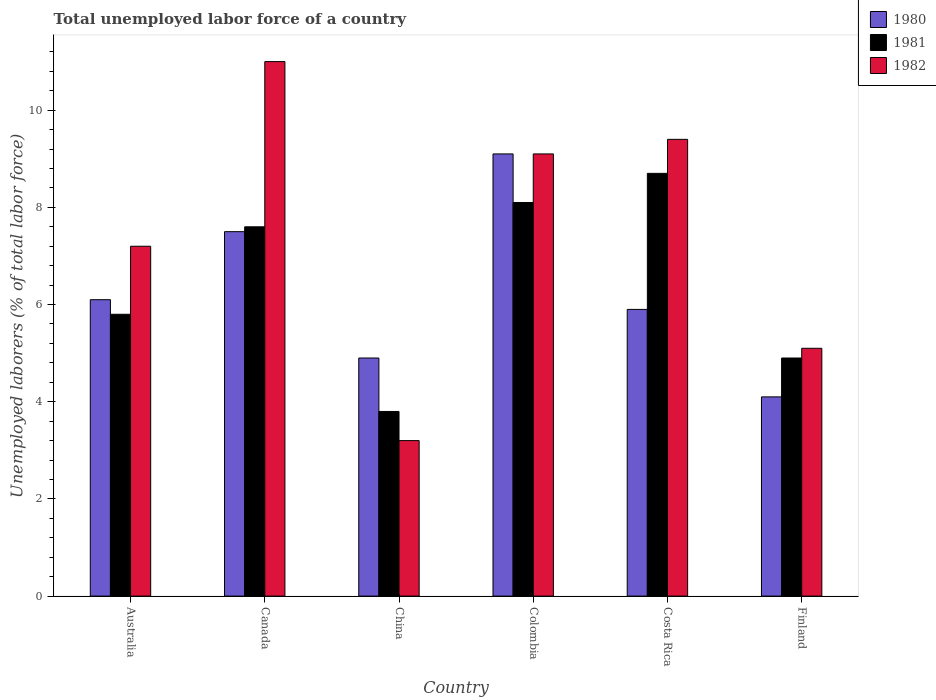How many groups of bars are there?
Your answer should be compact. 6. Are the number of bars on each tick of the X-axis equal?
Your answer should be compact. Yes. How many bars are there on the 4th tick from the right?
Keep it short and to the point. 3. What is the label of the 4th group of bars from the left?
Ensure brevity in your answer.  Colombia. In how many cases, is the number of bars for a given country not equal to the number of legend labels?
Keep it short and to the point. 0. What is the total unemployed labor force in 1982 in Finland?
Ensure brevity in your answer.  5.1. Across all countries, what is the maximum total unemployed labor force in 1980?
Offer a terse response. 9.1. Across all countries, what is the minimum total unemployed labor force in 1981?
Your response must be concise. 3.8. In which country was the total unemployed labor force in 1980 maximum?
Provide a short and direct response. Colombia. In which country was the total unemployed labor force in 1980 minimum?
Your answer should be compact. Finland. What is the total total unemployed labor force in 1981 in the graph?
Provide a short and direct response. 38.9. What is the difference between the total unemployed labor force in 1982 in Australia and that in Costa Rica?
Give a very brief answer. -2.2. What is the difference between the total unemployed labor force in 1981 in China and the total unemployed labor force in 1980 in Colombia?
Keep it short and to the point. -5.3. What is the average total unemployed labor force in 1981 per country?
Provide a succinct answer. 6.48. What is the difference between the total unemployed labor force of/in 1982 and total unemployed labor force of/in 1980 in Finland?
Keep it short and to the point. 1. What is the ratio of the total unemployed labor force in 1982 in China to that in Costa Rica?
Provide a succinct answer. 0.34. What is the difference between the highest and the second highest total unemployed labor force in 1981?
Your response must be concise. 0.6. What is the difference between the highest and the lowest total unemployed labor force in 1980?
Keep it short and to the point. 5. Is the sum of the total unemployed labor force in 1980 in Colombia and Costa Rica greater than the maximum total unemployed labor force in 1982 across all countries?
Offer a terse response. Yes. What does the 1st bar from the right in Costa Rica represents?
Your response must be concise. 1982. Is it the case that in every country, the sum of the total unemployed labor force in 1981 and total unemployed labor force in 1980 is greater than the total unemployed labor force in 1982?
Offer a terse response. Yes. How many bars are there?
Provide a short and direct response. 18. How many countries are there in the graph?
Your response must be concise. 6. Are the values on the major ticks of Y-axis written in scientific E-notation?
Provide a short and direct response. No. Does the graph contain any zero values?
Provide a short and direct response. No. How are the legend labels stacked?
Offer a very short reply. Vertical. What is the title of the graph?
Provide a short and direct response. Total unemployed labor force of a country. Does "1976" appear as one of the legend labels in the graph?
Ensure brevity in your answer.  No. What is the label or title of the X-axis?
Your answer should be compact. Country. What is the label or title of the Y-axis?
Offer a terse response. Unemployed laborers (% of total labor force). What is the Unemployed laborers (% of total labor force) in 1980 in Australia?
Your answer should be compact. 6.1. What is the Unemployed laborers (% of total labor force) in 1981 in Australia?
Your response must be concise. 5.8. What is the Unemployed laborers (% of total labor force) of 1982 in Australia?
Ensure brevity in your answer.  7.2. What is the Unemployed laborers (% of total labor force) in 1980 in Canada?
Your answer should be compact. 7.5. What is the Unemployed laborers (% of total labor force) in 1981 in Canada?
Keep it short and to the point. 7.6. What is the Unemployed laborers (% of total labor force) of 1982 in Canada?
Provide a short and direct response. 11. What is the Unemployed laborers (% of total labor force) in 1980 in China?
Give a very brief answer. 4.9. What is the Unemployed laborers (% of total labor force) of 1981 in China?
Make the answer very short. 3.8. What is the Unemployed laborers (% of total labor force) in 1982 in China?
Keep it short and to the point. 3.2. What is the Unemployed laborers (% of total labor force) of 1980 in Colombia?
Provide a succinct answer. 9.1. What is the Unemployed laborers (% of total labor force) of 1981 in Colombia?
Your answer should be compact. 8.1. What is the Unemployed laborers (% of total labor force) of 1982 in Colombia?
Keep it short and to the point. 9.1. What is the Unemployed laborers (% of total labor force) of 1980 in Costa Rica?
Ensure brevity in your answer.  5.9. What is the Unemployed laborers (% of total labor force) of 1981 in Costa Rica?
Your answer should be compact. 8.7. What is the Unemployed laborers (% of total labor force) in 1982 in Costa Rica?
Keep it short and to the point. 9.4. What is the Unemployed laborers (% of total labor force) of 1980 in Finland?
Ensure brevity in your answer.  4.1. What is the Unemployed laborers (% of total labor force) of 1981 in Finland?
Provide a succinct answer. 4.9. What is the Unemployed laborers (% of total labor force) of 1982 in Finland?
Ensure brevity in your answer.  5.1. Across all countries, what is the maximum Unemployed laborers (% of total labor force) of 1980?
Provide a succinct answer. 9.1. Across all countries, what is the maximum Unemployed laborers (% of total labor force) of 1981?
Your answer should be compact. 8.7. Across all countries, what is the maximum Unemployed laborers (% of total labor force) in 1982?
Offer a very short reply. 11. Across all countries, what is the minimum Unemployed laborers (% of total labor force) of 1980?
Your answer should be very brief. 4.1. Across all countries, what is the minimum Unemployed laborers (% of total labor force) of 1981?
Your answer should be compact. 3.8. Across all countries, what is the minimum Unemployed laborers (% of total labor force) of 1982?
Ensure brevity in your answer.  3.2. What is the total Unemployed laborers (% of total labor force) in 1980 in the graph?
Offer a terse response. 37.6. What is the total Unemployed laborers (% of total labor force) of 1981 in the graph?
Your answer should be compact. 38.9. What is the difference between the Unemployed laborers (% of total labor force) in 1981 in Australia and that in Canada?
Ensure brevity in your answer.  -1.8. What is the difference between the Unemployed laborers (% of total labor force) in 1982 in Australia and that in China?
Your answer should be very brief. 4. What is the difference between the Unemployed laborers (% of total labor force) in 1980 in Australia and that in Colombia?
Make the answer very short. -3. What is the difference between the Unemployed laborers (% of total labor force) in 1981 in Australia and that in Colombia?
Provide a succinct answer. -2.3. What is the difference between the Unemployed laborers (% of total labor force) in 1980 in Australia and that in Finland?
Your response must be concise. 2. What is the difference between the Unemployed laborers (% of total labor force) of 1982 in Australia and that in Finland?
Ensure brevity in your answer.  2.1. What is the difference between the Unemployed laborers (% of total labor force) in 1981 in Canada and that in China?
Make the answer very short. 3.8. What is the difference between the Unemployed laborers (% of total labor force) in 1980 in Canada and that in Colombia?
Give a very brief answer. -1.6. What is the difference between the Unemployed laborers (% of total labor force) in 1982 in Canada and that in Colombia?
Your answer should be very brief. 1.9. What is the difference between the Unemployed laborers (% of total labor force) in 1980 in Canada and that in Costa Rica?
Provide a succinct answer. 1.6. What is the difference between the Unemployed laborers (% of total labor force) of 1980 in Canada and that in Finland?
Your response must be concise. 3.4. What is the difference between the Unemployed laborers (% of total labor force) of 1982 in Canada and that in Finland?
Keep it short and to the point. 5.9. What is the difference between the Unemployed laborers (% of total labor force) in 1980 in China and that in Colombia?
Ensure brevity in your answer.  -4.2. What is the difference between the Unemployed laborers (% of total labor force) of 1980 in China and that in Costa Rica?
Keep it short and to the point. -1. What is the difference between the Unemployed laborers (% of total labor force) of 1982 in China and that in Costa Rica?
Offer a terse response. -6.2. What is the difference between the Unemployed laborers (% of total labor force) in 1981 in China and that in Finland?
Your answer should be very brief. -1.1. What is the difference between the Unemployed laborers (% of total labor force) in 1980 in Colombia and that in Costa Rica?
Provide a succinct answer. 3.2. What is the difference between the Unemployed laborers (% of total labor force) of 1981 in Colombia and that in Costa Rica?
Provide a short and direct response. -0.6. What is the difference between the Unemployed laborers (% of total labor force) of 1980 in Colombia and that in Finland?
Offer a terse response. 5. What is the difference between the Unemployed laborers (% of total labor force) of 1981 in Colombia and that in Finland?
Ensure brevity in your answer.  3.2. What is the difference between the Unemployed laborers (% of total labor force) in 1982 in Colombia and that in Finland?
Your answer should be very brief. 4. What is the difference between the Unemployed laborers (% of total labor force) in 1981 in Costa Rica and that in Finland?
Make the answer very short. 3.8. What is the difference between the Unemployed laborers (% of total labor force) of 1980 in Australia and the Unemployed laborers (% of total labor force) of 1982 in Canada?
Your answer should be very brief. -4.9. What is the difference between the Unemployed laborers (% of total labor force) in 1981 in Australia and the Unemployed laborers (% of total labor force) in 1982 in China?
Offer a very short reply. 2.6. What is the difference between the Unemployed laborers (% of total labor force) in 1980 in Australia and the Unemployed laborers (% of total labor force) in 1982 in Colombia?
Ensure brevity in your answer.  -3. What is the difference between the Unemployed laborers (% of total labor force) in 1981 in Australia and the Unemployed laborers (% of total labor force) in 1982 in Costa Rica?
Ensure brevity in your answer.  -3.6. What is the difference between the Unemployed laborers (% of total labor force) of 1980 in Canada and the Unemployed laborers (% of total labor force) of 1981 in China?
Provide a succinct answer. 3.7. What is the difference between the Unemployed laborers (% of total labor force) in 1980 in Canada and the Unemployed laborers (% of total labor force) in 1982 in China?
Your response must be concise. 4.3. What is the difference between the Unemployed laborers (% of total labor force) in 1980 in Canada and the Unemployed laborers (% of total labor force) in 1982 in Colombia?
Your answer should be very brief. -1.6. What is the difference between the Unemployed laborers (% of total labor force) in 1980 in Canada and the Unemployed laborers (% of total labor force) in 1981 in Costa Rica?
Give a very brief answer. -1.2. What is the difference between the Unemployed laborers (% of total labor force) in 1980 in Canada and the Unemployed laborers (% of total labor force) in 1982 in Costa Rica?
Provide a succinct answer. -1.9. What is the difference between the Unemployed laborers (% of total labor force) of 1981 in Canada and the Unemployed laborers (% of total labor force) of 1982 in Costa Rica?
Provide a succinct answer. -1.8. What is the difference between the Unemployed laborers (% of total labor force) in 1980 in Canada and the Unemployed laborers (% of total labor force) in 1981 in Finland?
Provide a short and direct response. 2.6. What is the difference between the Unemployed laborers (% of total labor force) in 1981 in China and the Unemployed laborers (% of total labor force) in 1982 in Colombia?
Offer a terse response. -5.3. What is the difference between the Unemployed laborers (% of total labor force) of 1980 in China and the Unemployed laborers (% of total labor force) of 1982 in Costa Rica?
Provide a short and direct response. -4.5. What is the difference between the Unemployed laborers (% of total labor force) of 1980 in China and the Unemployed laborers (% of total labor force) of 1981 in Finland?
Your answer should be compact. 0. What is the difference between the Unemployed laborers (% of total labor force) of 1981 in China and the Unemployed laborers (% of total labor force) of 1982 in Finland?
Give a very brief answer. -1.3. What is the difference between the Unemployed laborers (% of total labor force) in 1981 in Colombia and the Unemployed laborers (% of total labor force) in 1982 in Costa Rica?
Your response must be concise. -1.3. What is the average Unemployed laborers (% of total labor force) of 1980 per country?
Provide a succinct answer. 6.27. What is the average Unemployed laborers (% of total labor force) of 1981 per country?
Your answer should be compact. 6.48. What is the difference between the Unemployed laborers (% of total labor force) in 1980 and Unemployed laborers (% of total labor force) in 1981 in Australia?
Give a very brief answer. 0.3. What is the difference between the Unemployed laborers (% of total labor force) in 1981 and Unemployed laborers (% of total labor force) in 1982 in Australia?
Provide a succinct answer. -1.4. What is the difference between the Unemployed laborers (% of total labor force) of 1980 and Unemployed laborers (% of total labor force) of 1982 in Canada?
Offer a terse response. -3.5. What is the difference between the Unemployed laborers (% of total labor force) in 1981 and Unemployed laborers (% of total labor force) in 1982 in Canada?
Offer a terse response. -3.4. What is the difference between the Unemployed laborers (% of total labor force) in 1980 and Unemployed laborers (% of total labor force) in 1982 in China?
Offer a terse response. 1.7. What is the difference between the Unemployed laborers (% of total labor force) of 1981 and Unemployed laborers (% of total labor force) of 1982 in China?
Provide a succinct answer. 0.6. What is the difference between the Unemployed laborers (% of total labor force) of 1980 and Unemployed laborers (% of total labor force) of 1981 in Colombia?
Give a very brief answer. 1. What is the difference between the Unemployed laborers (% of total labor force) in 1981 and Unemployed laborers (% of total labor force) in 1982 in Colombia?
Provide a succinct answer. -1. What is the difference between the Unemployed laborers (% of total labor force) in 1980 and Unemployed laborers (% of total labor force) in 1982 in Costa Rica?
Provide a short and direct response. -3.5. What is the difference between the Unemployed laborers (% of total labor force) in 1981 and Unemployed laborers (% of total labor force) in 1982 in Costa Rica?
Provide a succinct answer. -0.7. What is the difference between the Unemployed laborers (% of total labor force) in 1980 and Unemployed laborers (% of total labor force) in 1981 in Finland?
Provide a short and direct response. -0.8. What is the difference between the Unemployed laborers (% of total labor force) of 1980 and Unemployed laborers (% of total labor force) of 1982 in Finland?
Offer a terse response. -1. What is the difference between the Unemployed laborers (% of total labor force) in 1981 and Unemployed laborers (% of total labor force) in 1982 in Finland?
Provide a succinct answer. -0.2. What is the ratio of the Unemployed laborers (% of total labor force) in 1980 in Australia to that in Canada?
Ensure brevity in your answer.  0.81. What is the ratio of the Unemployed laborers (% of total labor force) of 1981 in Australia to that in Canada?
Make the answer very short. 0.76. What is the ratio of the Unemployed laborers (% of total labor force) of 1982 in Australia to that in Canada?
Ensure brevity in your answer.  0.65. What is the ratio of the Unemployed laborers (% of total labor force) of 1980 in Australia to that in China?
Give a very brief answer. 1.24. What is the ratio of the Unemployed laborers (% of total labor force) of 1981 in Australia to that in China?
Your answer should be very brief. 1.53. What is the ratio of the Unemployed laborers (% of total labor force) of 1982 in Australia to that in China?
Your answer should be very brief. 2.25. What is the ratio of the Unemployed laborers (% of total labor force) of 1980 in Australia to that in Colombia?
Your answer should be compact. 0.67. What is the ratio of the Unemployed laborers (% of total labor force) of 1981 in Australia to that in Colombia?
Ensure brevity in your answer.  0.72. What is the ratio of the Unemployed laborers (% of total labor force) of 1982 in Australia to that in Colombia?
Ensure brevity in your answer.  0.79. What is the ratio of the Unemployed laborers (% of total labor force) of 1980 in Australia to that in Costa Rica?
Your answer should be compact. 1.03. What is the ratio of the Unemployed laborers (% of total labor force) in 1981 in Australia to that in Costa Rica?
Provide a short and direct response. 0.67. What is the ratio of the Unemployed laborers (% of total labor force) of 1982 in Australia to that in Costa Rica?
Make the answer very short. 0.77. What is the ratio of the Unemployed laborers (% of total labor force) in 1980 in Australia to that in Finland?
Provide a succinct answer. 1.49. What is the ratio of the Unemployed laborers (% of total labor force) of 1981 in Australia to that in Finland?
Offer a very short reply. 1.18. What is the ratio of the Unemployed laborers (% of total labor force) in 1982 in Australia to that in Finland?
Your answer should be very brief. 1.41. What is the ratio of the Unemployed laborers (% of total labor force) of 1980 in Canada to that in China?
Your answer should be compact. 1.53. What is the ratio of the Unemployed laborers (% of total labor force) of 1981 in Canada to that in China?
Your response must be concise. 2. What is the ratio of the Unemployed laborers (% of total labor force) of 1982 in Canada to that in China?
Your answer should be compact. 3.44. What is the ratio of the Unemployed laborers (% of total labor force) of 1980 in Canada to that in Colombia?
Ensure brevity in your answer.  0.82. What is the ratio of the Unemployed laborers (% of total labor force) in 1981 in Canada to that in Colombia?
Your answer should be very brief. 0.94. What is the ratio of the Unemployed laborers (% of total labor force) in 1982 in Canada to that in Colombia?
Make the answer very short. 1.21. What is the ratio of the Unemployed laborers (% of total labor force) of 1980 in Canada to that in Costa Rica?
Ensure brevity in your answer.  1.27. What is the ratio of the Unemployed laborers (% of total labor force) in 1981 in Canada to that in Costa Rica?
Make the answer very short. 0.87. What is the ratio of the Unemployed laborers (% of total labor force) in 1982 in Canada to that in Costa Rica?
Provide a short and direct response. 1.17. What is the ratio of the Unemployed laborers (% of total labor force) of 1980 in Canada to that in Finland?
Your answer should be very brief. 1.83. What is the ratio of the Unemployed laborers (% of total labor force) of 1981 in Canada to that in Finland?
Your answer should be very brief. 1.55. What is the ratio of the Unemployed laborers (% of total labor force) in 1982 in Canada to that in Finland?
Your answer should be very brief. 2.16. What is the ratio of the Unemployed laborers (% of total labor force) in 1980 in China to that in Colombia?
Your response must be concise. 0.54. What is the ratio of the Unemployed laborers (% of total labor force) in 1981 in China to that in Colombia?
Provide a short and direct response. 0.47. What is the ratio of the Unemployed laborers (% of total labor force) in 1982 in China to that in Colombia?
Provide a succinct answer. 0.35. What is the ratio of the Unemployed laborers (% of total labor force) in 1980 in China to that in Costa Rica?
Provide a succinct answer. 0.83. What is the ratio of the Unemployed laborers (% of total labor force) in 1981 in China to that in Costa Rica?
Make the answer very short. 0.44. What is the ratio of the Unemployed laborers (% of total labor force) of 1982 in China to that in Costa Rica?
Offer a very short reply. 0.34. What is the ratio of the Unemployed laborers (% of total labor force) in 1980 in China to that in Finland?
Offer a terse response. 1.2. What is the ratio of the Unemployed laborers (% of total labor force) in 1981 in China to that in Finland?
Provide a succinct answer. 0.78. What is the ratio of the Unemployed laborers (% of total labor force) of 1982 in China to that in Finland?
Your response must be concise. 0.63. What is the ratio of the Unemployed laborers (% of total labor force) of 1980 in Colombia to that in Costa Rica?
Keep it short and to the point. 1.54. What is the ratio of the Unemployed laborers (% of total labor force) in 1982 in Colombia to that in Costa Rica?
Give a very brief answer. 0.97. What is the ratio of the Unemployed laborers (% of total labor force) of 1980 in Colombia to that in Finland?
Give a very brief answer. 2.22. What is the ratio of the Unemployed laborers (% of total labor force) in 1981 in Colombia to that in Finland?
Keep it short and to the point. 1.65. What is the ratio of the Unemployed laborers (% of total labor force) of 1982 in Colombia to that in Finland?
Provide a succinct answer. 1.78. What is the ratio of the Unemployed laborers (% of total labor force) of 1980 in Costa Rica to that in Finland?
Keep it short and to the point. 1.44. What is the ratio of the Unemployed laborers (% of total labor force) in 1981 in Costa Rica to that in Finland?
Your answer should be very brief. 1.78. What is the ratio of the Unemployed laborers (% of total labor force) of 1982 in Costa Rica to that in Finland?
Your answer should be very brief. 1.84. What is the difference between the highest and the second highest Unemployed laborers (% of total labor force) of 1981?
Your response must be concise. 0.6. What is the difference between the highest and the lowest Unemployed laborers (% of total labor force) of 1982?
Provide a succinct answer. 7.8. 